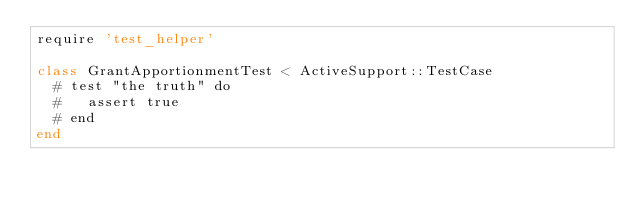<code> <loc_0><loc_0><loc_500><loc_500><_Ruby_>require 'test_helper'

class GrantApportionmentTest < ActiveSupport::TestCase
  # test "the truth" do
  #   assert true
  # end
end
</code> 